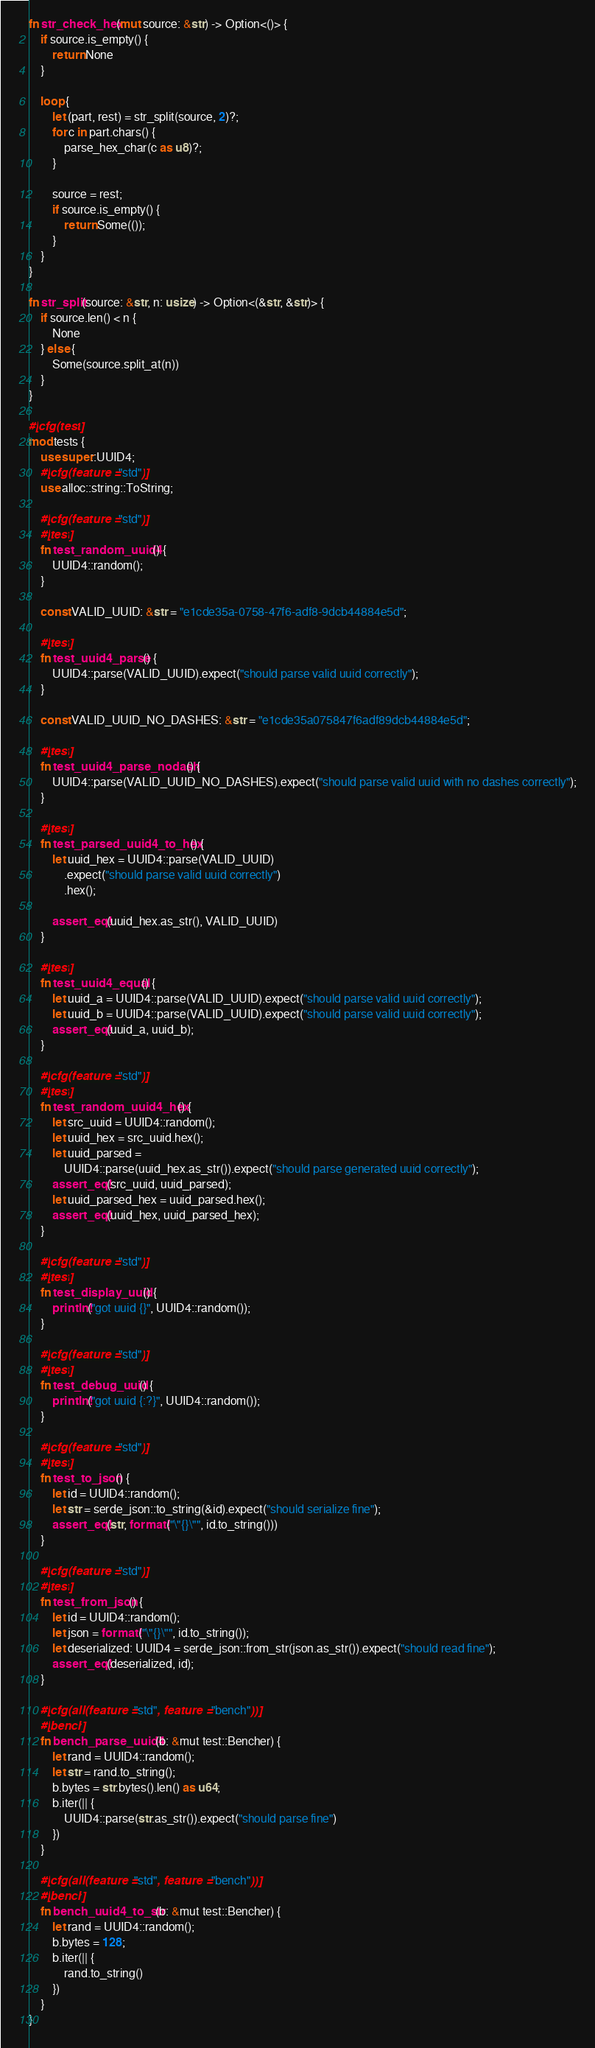<code> <loc_0><loc_0><loc_500><loc_500><_Rust_>
fn str_check_hex(mut source: &str) -> Option<()> {
    if source.is_empty() {
        return None
    }

    loop {
        let (part, rest) = str_split(source, 2)?;
        for c in part.chars() {
            parse_hex_char(c as u8)?;
        }

        source = rest;
        if source.is_empty() {
            return Some(());
        }
    }
}

fn str_split(source: &str, n: usize) -> Option<(&str, &str)> {
    if source.len() < n {
        None
    } else {
        Some(source.split_at(n))
    }
}

#[cfg(test)]
mod tests {
    use super::UUID4;
    #[cfg(feature = "std")]
    use alloc::string::ToString;

    #[cfg(feature = "std")]
    #[test]
    fn test_random_uuid4() {
        UUID4::random();
    }

    const VALID_UUID: &str = "e1cde35a-0758-47f6-adf8-9dcb44884e5d";

    #[test]
    fn test_uuid4_parse() {
        UUID4::parse(VALID_UUID).expect("should parse valid uuid correctly");
    }

    const VALID_UUID_NO_DASHES: &str = "e1cde35a075847f6adf89dcb44884e5d";

    #[test]
    fn test_uuid4_parse_nodash() {
        UUID4::parse(VALID_UUID_NO_DASHES).expect("should parse valid uuid with no dashes correctly");
    }

    #[test]
    fn test_parsed_uuid4_to_hex() {
        let uuid_hex = UUID4::parse(VALID_UUID)
            .expect("should parse valid uuid correctly")
            .hex();

        assert_eq!(uuid_hex.as_str(), VALID_UUID)
    }

    #[test]
    fn test_uuid4_equal() {
        let uuid_a = UUID4::parse(VALID_UUID).expect("should parse valid uuid correctly");
        let uuid_b = UUID4::parse(VALID_UUID).expect("should parse valid uuid correctly");
        assert_eq!(uuid_a, uuid_b);
    }

    #[cfg(feature = "std")]
    #[test]
    fn test_random_uuid4_hex() {
        let src_uuid = UUID4::random();
        let uuid_hex = src_uuid.hex();
        let uuid_parsed =
            UUID4::parse(uuid_hex.as_str()).expect("should parse generated uuid correctly");
        assert_eq!(src_uuid, uuid_parsed);
        let uuid_parsed_hex = uuid_parsed.hex();
        assert_eq!(uuid_hex, uuid_parsed_hex);
    }

    #[cfg(feature = "std")]
    #[test]
    fn test_display_uuid() {
        println!("got uuid {}", UUID4::random());
    }

    #[cfg(feature = "std")]
    #[test]
    fn test_debug_uuid() {
        println!("got uuid {:?}", UUID4::random());
    }

    #[cfg(feature = "std")]
    #[test]
    fn test_to_json() {
        let id = UUID4::random();
        let str = serde_json::to_string(&id).expect("should serialize fine");
        assert_eq!(str, format!("\"{}\"", id.to_string()))
    }

    #[cfg(feature = "std")]
    #[test]
    fn test_from_json() {
        let id = UUID4::random();
        let json = format!("\"{}\"", id.to_string());
        let deserialized: UUID4 = serde_json::from_str(json.as_str()).expect("should read fine");
        assert_eq!(deserialized, id);
    }

    #[cfg(all(feature = "std", feature = "bench"))]
    #[bench]
    fn bench_parse_uuid4(b: &mut test::Bencher) {
        let rand = UUID4::random();
        let str = rand.to_string();
        b.bytes = str.bytes().len() as u64;
        b.iter(|| {
            UUID4::parse(str.as_str()).expect("should parse fine")
        })
    }

    #[cfg(all(feature = "std", feature = "bench"))]
    #[bench]
    fn bench_uuid4_to_str(b: &mut test::Bencher) {
        let rand = UUID4::random();
        b.bytes = 128;
        b.iter(|| {
            rand.to_string()
        })
    }
}
</code> 